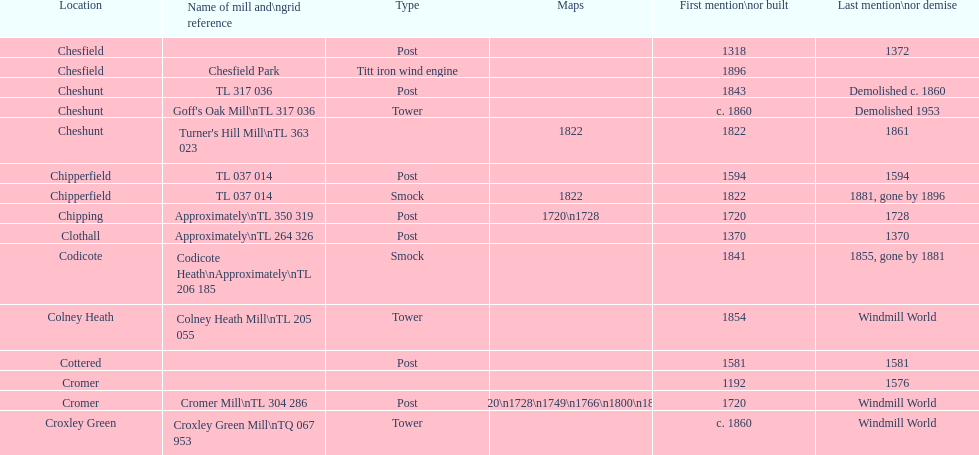How man "c" windmills have there been? 15. 